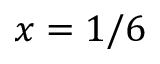<formula> <loc_0><loc_0><loc_500><loc_500>x = 1 / 6</formula> 